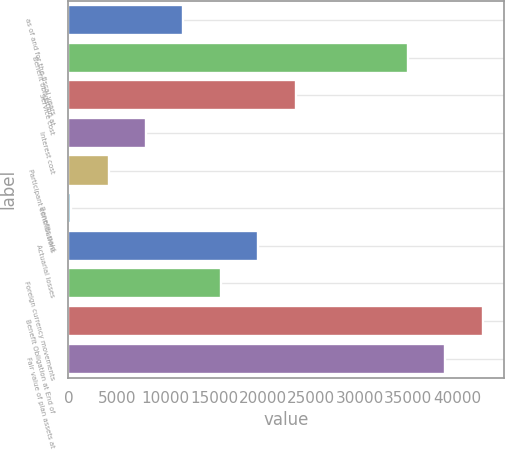Convert chart to OTSL. <chart><loc_0><loc_0><loc_500><loc_500><bar_chart><fcel>as of and for the fiscal years<fcel>Benefit obligation at<fcel>Service cost<fcel>Interest cost<fcel>Participant contributions<fcel>Benefits paid<fcel>Actuarial losses<fcel>Foreign currency movements<fcel>Benefit Obligation at End of<fcel>Fair value of plan assets at<nl><fcel>11848.1<fcel>34958.3<fcel>23403.2<fcel>7996.4<fcel>4144.7<fcel>293<fcel>19551.5<fcel>15699.8<fcel>42661.7<fcel>38810<nl></chart> 